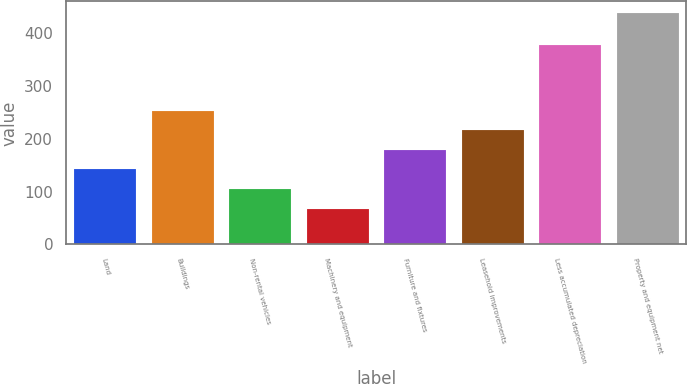Convert chart. <chart><loc_0><loc_0><loc_500><loc_500><bar_chart><fcel>Land<fcel>Buildings<fcel>Non-rental vehicles<fcel>Machinery and equipment<fcel>Furniture and fixtures<fcel>Leasehold improvements<fcel>Less accumulated depreciation<fcel>Property and equipment net<nl><fcel>142<fcel>253<fcel>105<fcel>68<fcel>179<fcel>216<fcel>377<fcel>438<nl></chart> 